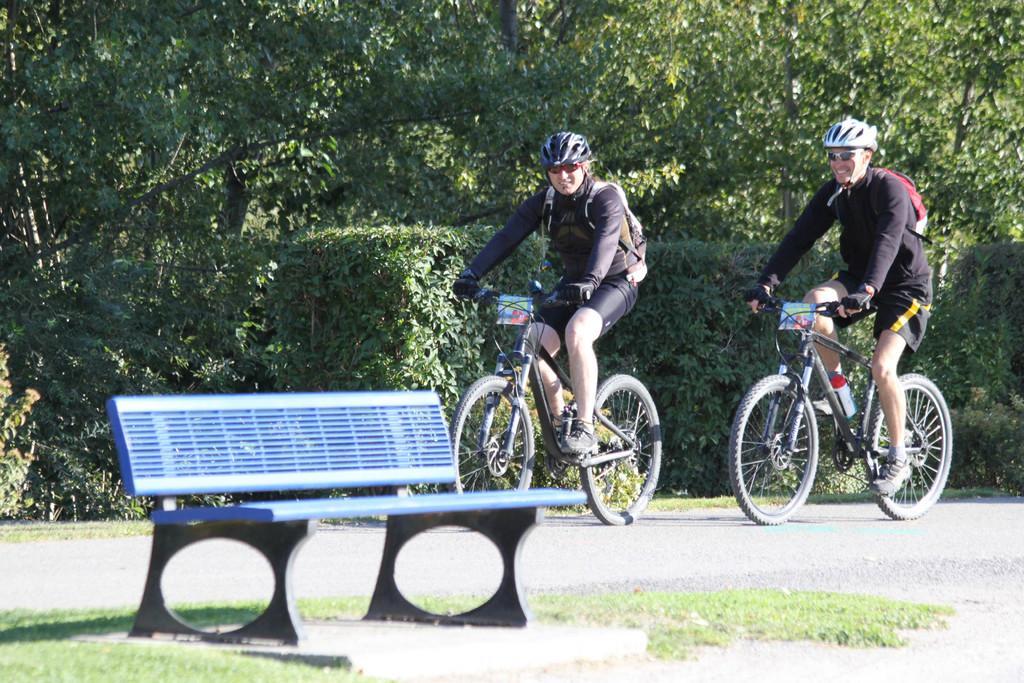Please provide a concise description of this image. In this image we can see two persons wearing the helmets and also glasses and riding the bicycles on the road. We can also see the bench, grass and also trees in the background. 